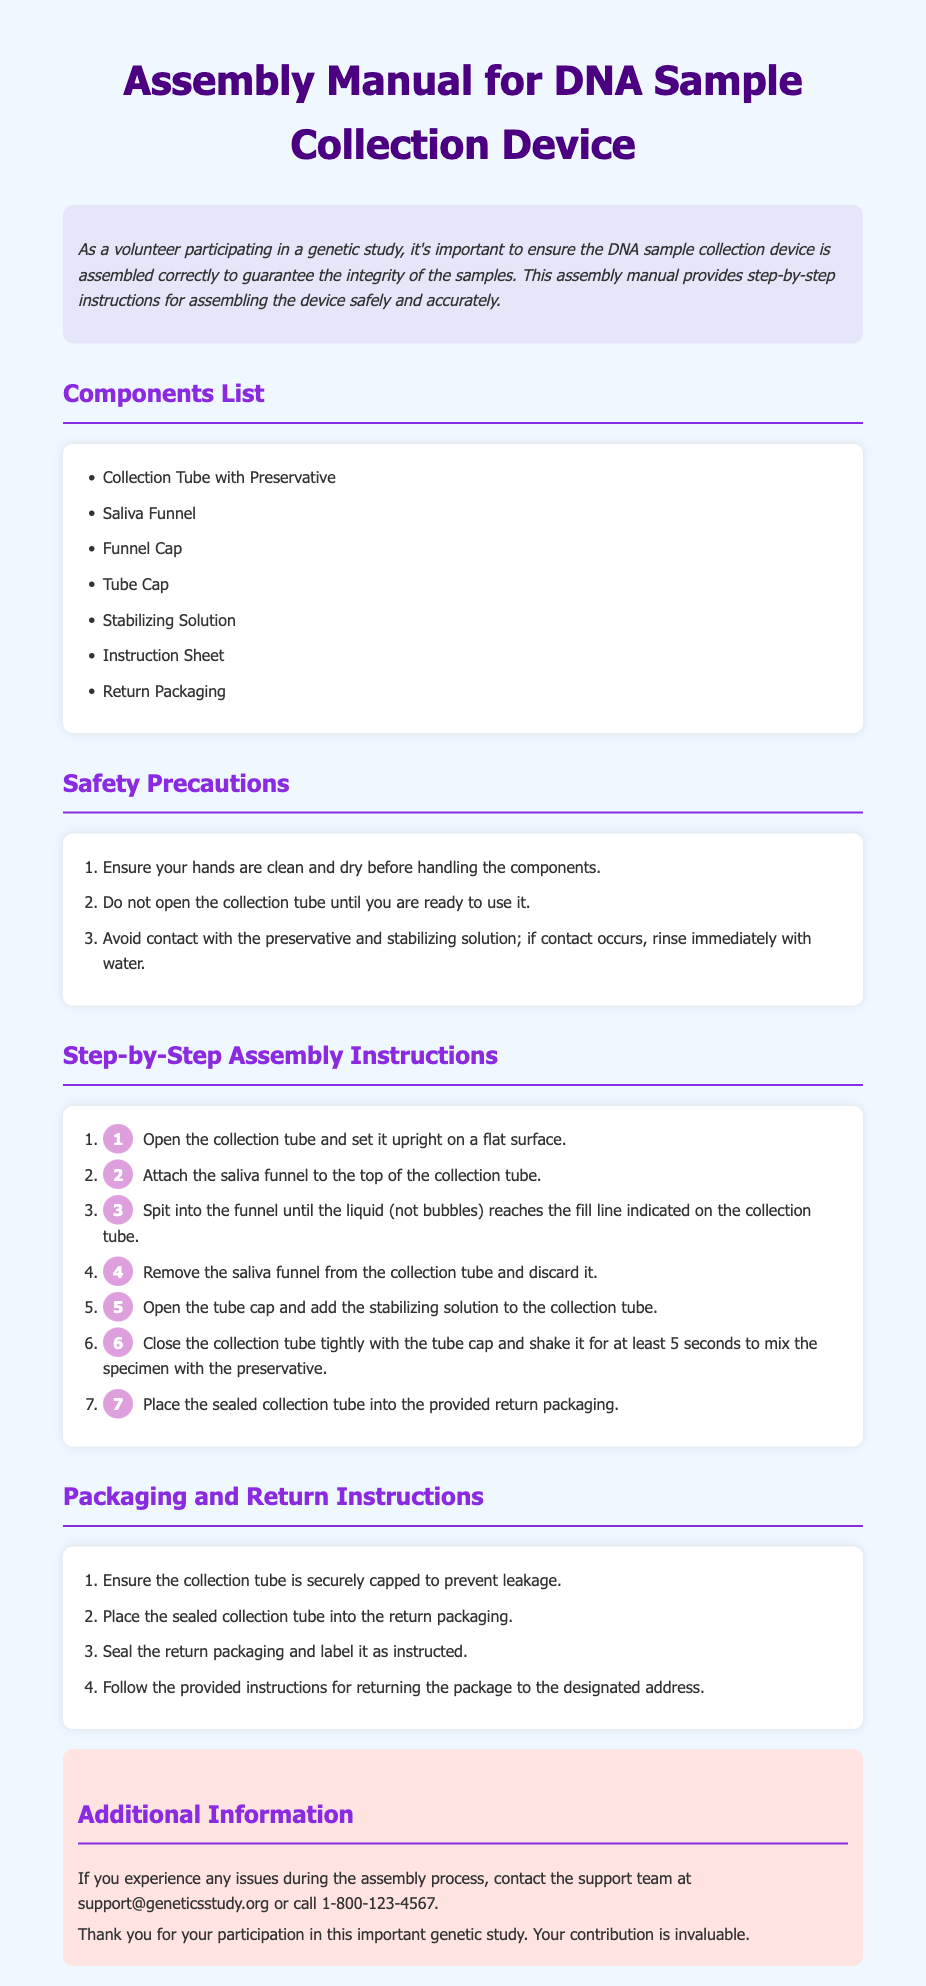What is the title of the document? The title of the document is presented at the top of the page, indicating the purpose of the content.
Answer: Assembly Manual for DNA Sample Collection Device How many components are listed? The number of components is given in the "Components List" section.
Answer: Seven What should you do before handling the components? The safety precautions section advises on necessary actions prior to handling, indicating hygiene.
Answer: Clean and dry hands What is the first step in the assembly process? The initial step is indicated explicitly in the "Step-by-Step Assembly Instructions" section.
Answer: Open the collection tube What do you do with the saliva funnel after use? Instructions in the assembly process detail the next action after using the funnel.
Answer: Discard it What is the tube cap used for? The step-by-step instructions explain the purpose of the tube cap in the assembly process.
Answer: Close collection tube How long should you shake the tube? The instructions specify the duration for mixing the specimen within the tube.
Answer: At least 5 seconds What should you ensure before placing the tube in return packaging? This requirement is stated in the "Packaging and Return Instructions" section, emphasizing safety and security.
Answer: Securely capped Where can you get support if issues arise? The additional information section provides contact details for support in case of problems.
Answer: support@geneticsstudy.org 